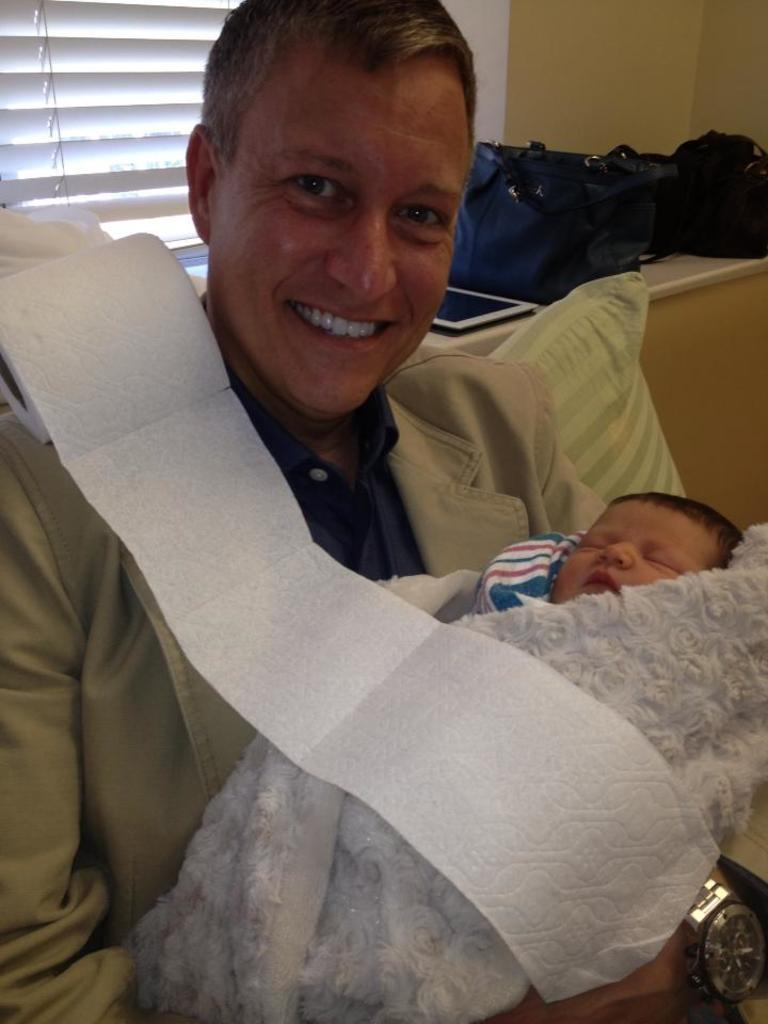What is the person in the image doing with the baby? The person is holding a baby in the image. What can be seen in the background of the image? There are bags and objects on the wall visible in the background. What type of structure is present in the image? There is a wall visible in the image. Is there any source of natural light in the image? Yes, there is a window in the image. What type of riddle can be solved by the baby in the image? There is no riddle present in the image, nor is the baby solving any riddles. 